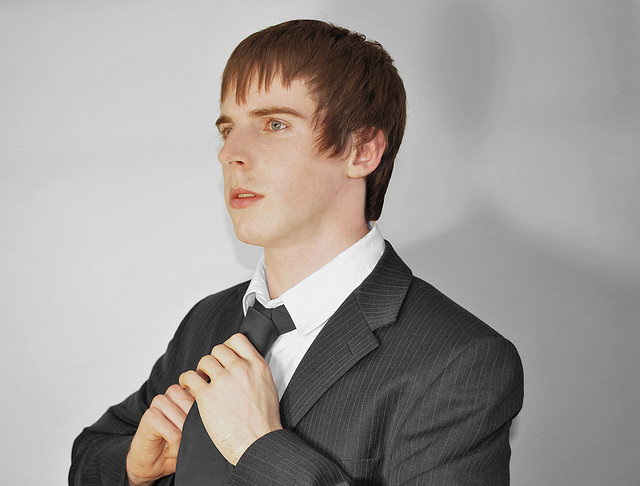<image>What is the man looking at? I am not sure what the man is looking at. It could be a mirror, a window, or something in the distance. What is the man looking at? I don't know what the man is looking at. It could be himself, the distance, the wall, the mirror, or the window. 